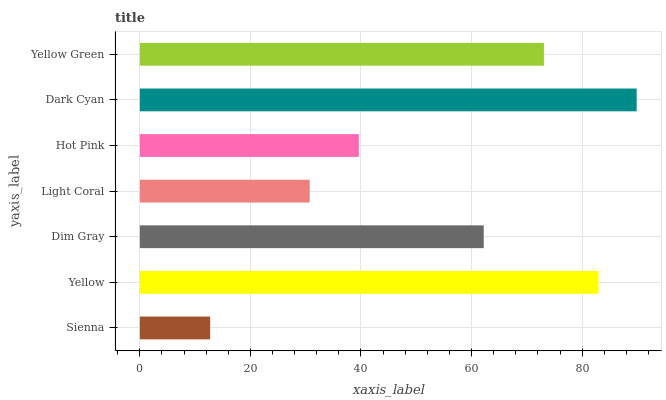Is Sienna the minimum?
Answer yes or no. Yes. Is Dark Cyan the maximum?
Answer yes or no. Yes. Is Yellow the minimum?
Answer yes or no. No. Is Yellow the maximum?
Answer yes or no. No. Is Yellow greater than Sienna?
Answer yes or no. Yes. Is Sienna less than Yellow?
Answer yes or no. Yes. Is Sienna greater than Yellow?
Answer yes or no. No. Is Yellow less than Sienna?
Answer yes or no. No. Is Dim Gray the high median?
Answer yes or no. Yes. Is Dim Gray the low median?
Answer yes or no. Yes. Is Sienna the high median?
Answer yes or no. No. Is Yellow the low median?
Answer yes or no. No. 